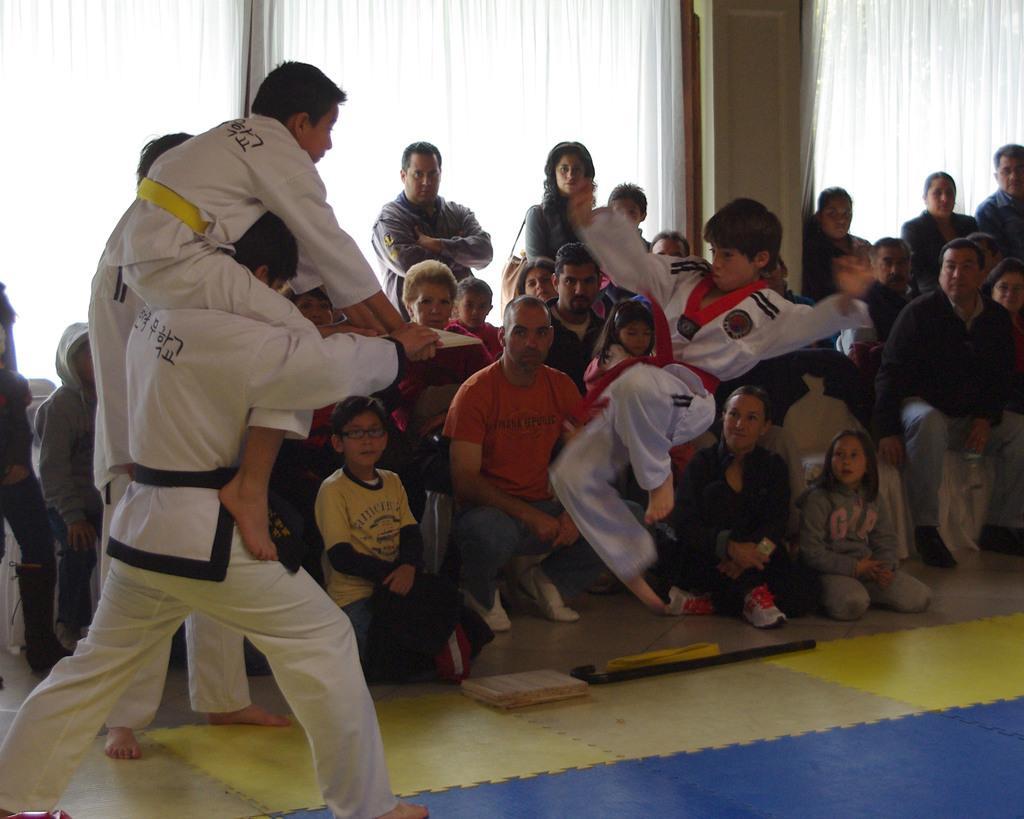How would you summarize this image in a sentence or two? In this image there is a person sitting on other person. A boy is jumping in air. Few persons are sitting on the chairs. Few persons are on the floor having few wooden planks on it. Few persons are standing on the floor. Background there are windows covered with curtain. 